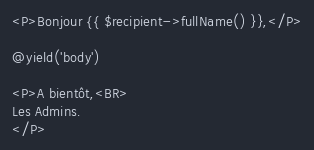<code> <loc_0><loc_0><loc_500><loc_500><_PHP_><P>Bonjour {{ $recipient->fullName() }},</P>

@yield('body')

<P>A bientôt,<BR>
Les Admins.
</P>
</code> 